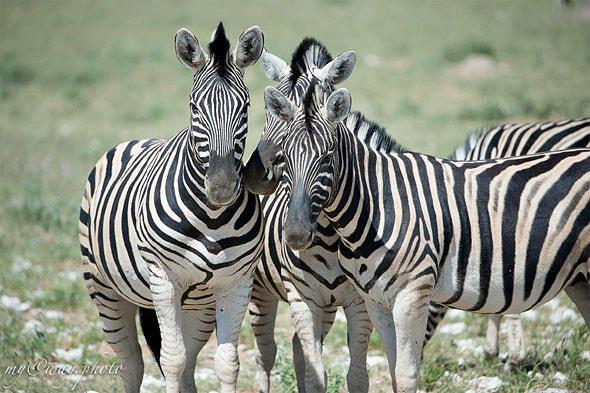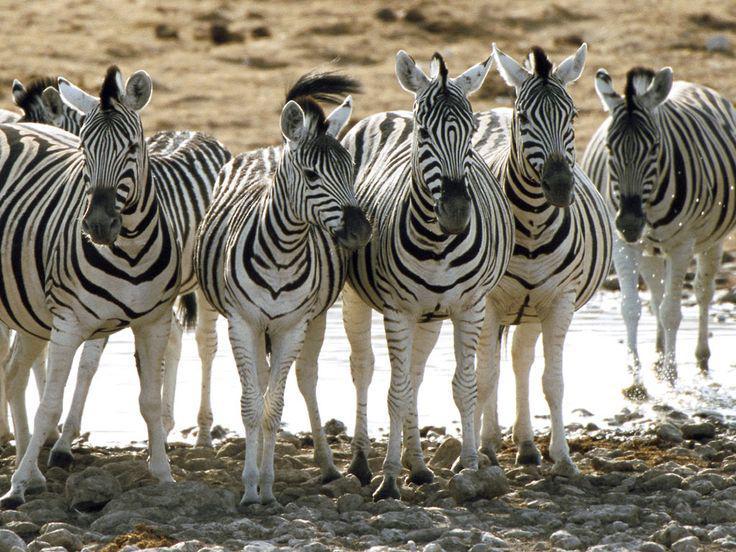The first image is the image on the left, the second image is the image on the right. Analyze the images presented: Is the assertion "One image shows two zebra standing in profile turned toward one another, each one with its head over the back of the other." valid? Answer yes or no. No. The first image is the image on the left, the second image is the image on the right. Given the left and right images, does the statement "The left image contains no more than one zebra." hold true? Answer yes or no. No. 